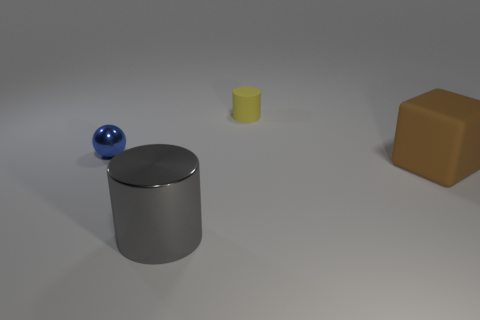There is a brown thing; is it the same size as the matte object that is behind the blue metal object? no 